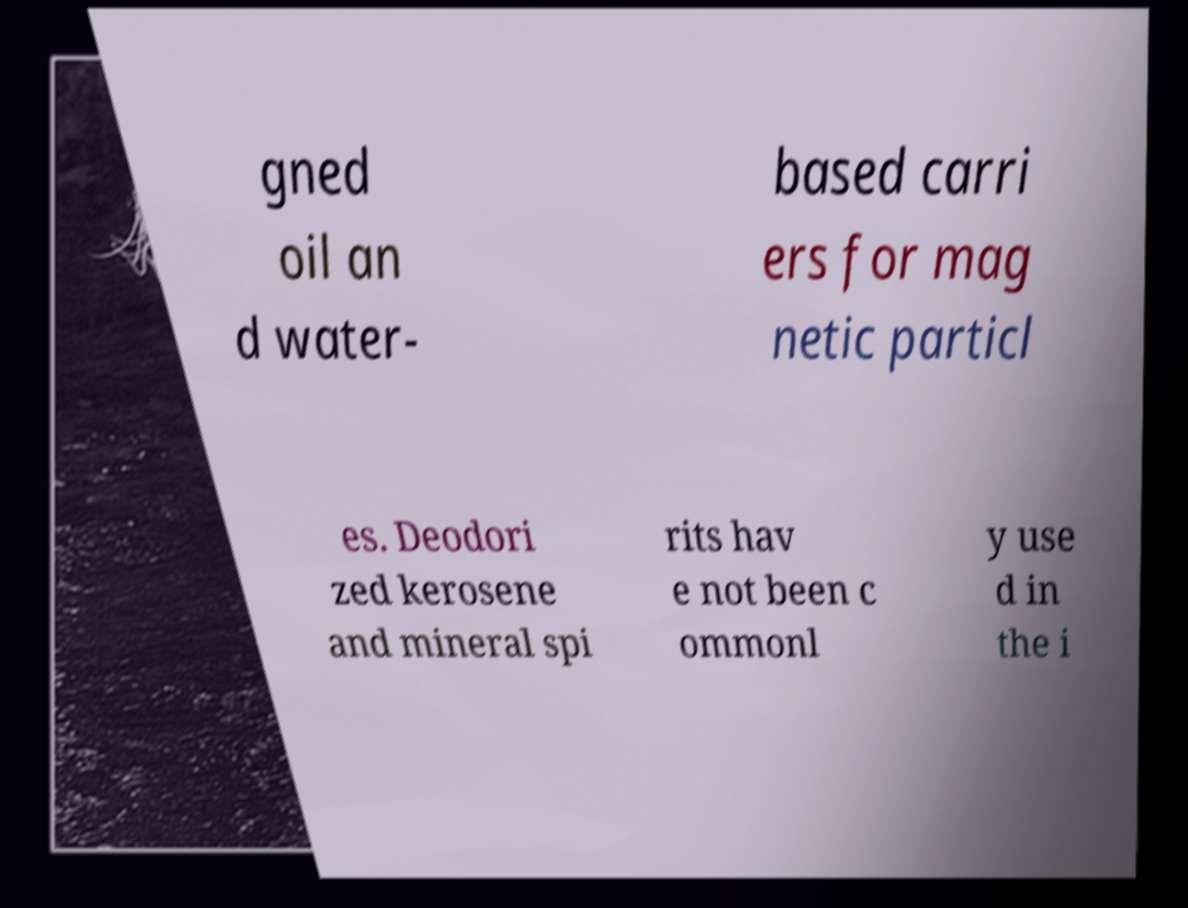Please identify and transcribe the text found in this image. gned oil an d water- based carri ers for mag netic particl es. Deodori zed kerosene and mineral spi rits hav e not been c ommonl y use d in the i 